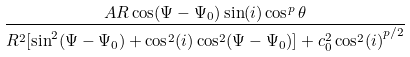Convert formula to latex. <formula><loc_0><loc_0><loc_500><loc_500>\frac { A R \cos ( \Psi - \Psi _ { 0 } ) \sin ( i ) \cos ^ { p } \theta } { { R ^ { 2 } [ \sin ^ { 2 } ( \Psi - \Psi _ { 0 } ) + \cos ^ { 2 } ( i ) \cos ^ { 2 } ( \Psi - \Psi _ { 0 } ) ] + c ^ { 2 } _ { 0 } \cos ^ { 2 } ( i ) } ^ { p / 2 } }</formula> 